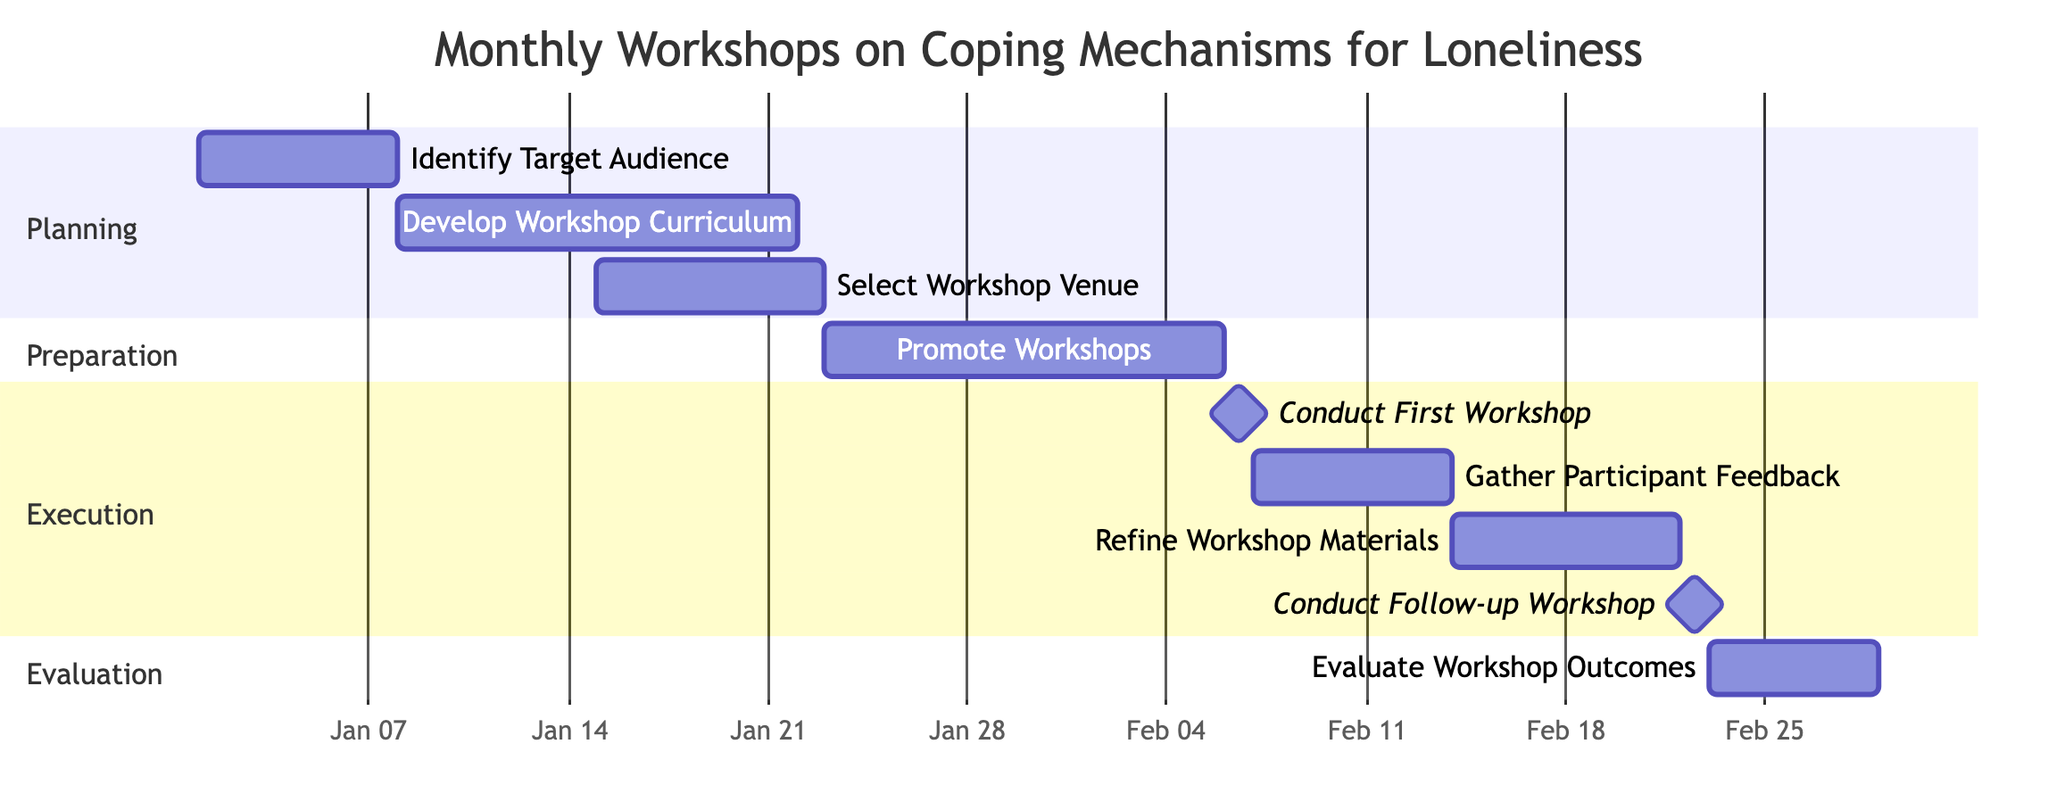What is the duration of the "Identify Target Audience" task? The task "Identify Target Audience" has a duration specified as "7 days". This information can be found by locating the task in the diagram and reading the duration directly associated with it.
Answer: 7 days Which task immediately follows "Gather Participant Feedback"? In the Gantt Chart, "Refine Workshop Materials" follows "Gather Participant Feedback" directly. This can be verified by tracing the flow from "Gather Participant Feedback" to the next task listed in the execution section.
Answer: Refine Workshop Materials What is the total number of tasks in the diagram? By counting all the tasks listed in the Gantt Chart, we find there are nine distinct tasks, each identified under the relevant sections.
Answer: 9 On what date is the "Conduct First Workshop" scheduled? The date for "Conduct First Workshop" is indicated directly in the diagram as "2024-02-06". This date can be found within the task description itself.
Answer: 2024-02-06 How many days are there between the "Conduct First Workshop" and the "Evaluate Workshop Outcomes"? The "Conduct First Workshop" ends on "2024-02-06" and "Evaluate Workshop Outcomes" starts on "2024-02-23". To find the gap, count from the end date of the first workshop to the start date of the evaluation, which is a total of 17 days.
Answer: 17 days What is the final task in the Gantt chart? The final task listed in the Gantt Chart is "Evaluate Workshop Outcomes". This can be determined by looking at the list of tasks and identifying the one that appears last in the sequence.
Answer: Evaluate Workshop Outcomes Which task overlaps with "Promote Workshops"? The task "Select Workshop Venue" overlaps with "Promote Workshops", as "Select Workshop Venue" runs from "2024-01-15" to "2024-01-22," while "Promote Workshops" starts on "2024-01-23" and runs until "2024-02-05". Overlapping tasks are determined by their respective date ranges.
Answer: Select Workshop Venue What is the duration of the "Conduct Follow-up Workshop"? The duration of "Conduct Follow-up Workshop" is specified as "1 day". This information is clearly stated alongside the task in the diagram and can be referred to directly.
Answer: 1 day In which section is the "Develop Workshop Curriculum" task located? The task "Develop Workshop Curriculum" is located in the "Planning" section of the Gantt Chart. Each task is categorized, and this particular task falls under the initial planning phase.
Answer: Planning 